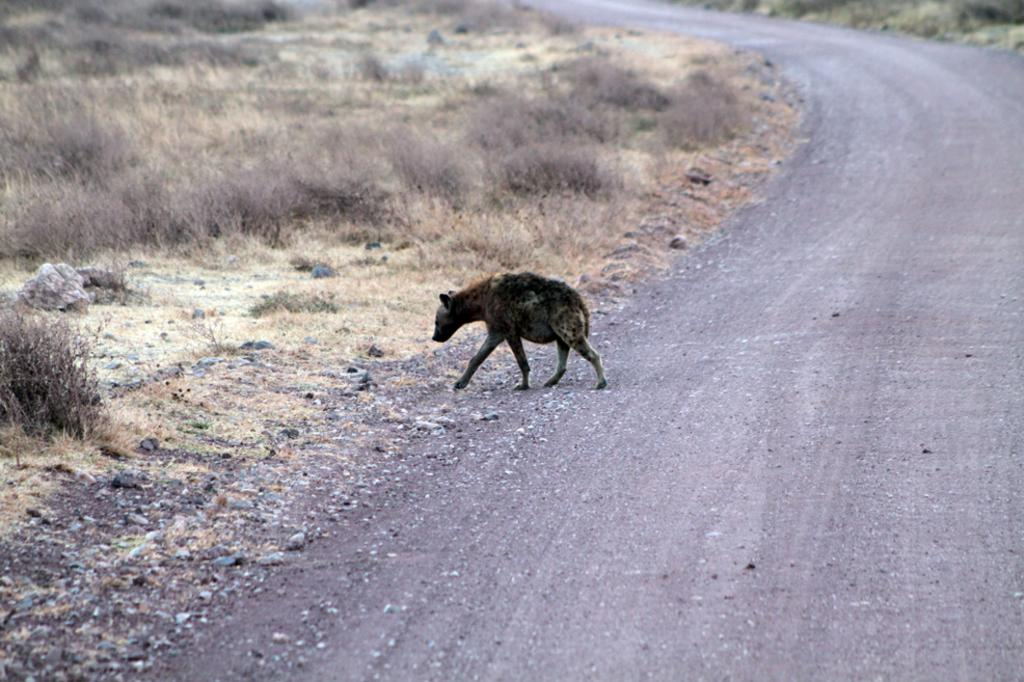What type of animal is in the image? There is an animal in the image, but the specific type is not mentioned in the facts. What is the animal doing in the image? The animal is walking in the image. What is at the bottom of the image? There is a road at the bottom of the image. What can be seen on the ground to the left of the image? There is dry grass on the ground to the left of the image. How many guns are visible in the image? There are no guns present in the image. What type of bikes are being ridden by the animal in the image? There are no bikes present in the image, and the animal is walking, not riding a bike. 